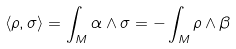<formula> <loc_0><loc_0><loc_500><loc_500>\langle \rho , \sigma \rangle = \int _ { M } \alpha \wedge \sigma = - \int _ { M } \rho \wedge \beta</formula> 